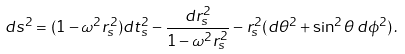Convert formula to latex. <formula><loc_0><loc_0><loc_500><loc_500>d s ^ { 2 } = ( 1 - \omega ^ { 2 } r _ { s } ^ { 2 } ) d t _ { s } ^ { 2 } - \frac { d r ^ { 2 } _ { s } } { 1 - \omega ^ { 2 } r _ { s } ^ { 2 } } - r ^ { 2 } _ { s } ( d \theta ^ { 2 } + \sin ^ { 2 } \theta \, d \phi ^ { 2 } ) \, .</formula> 